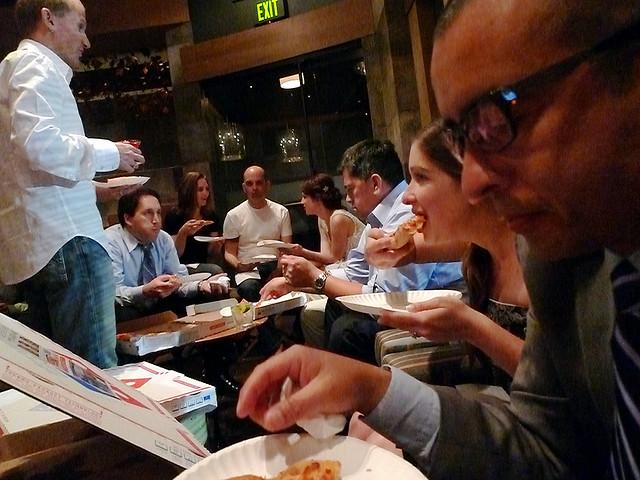Where is the exit sign?
Short answer required. Over doorway. How many women are in this photo?
Concise answer only. 3. What are the people eating?
Be succinct. Pizza. 